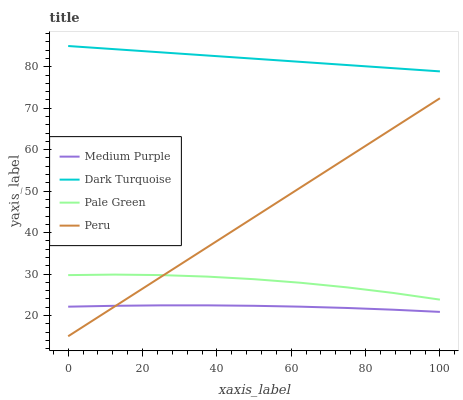Does Medium Purple have the minimum area under the curve?
Answer yes or no. Yes. Does Dark Turquoise have the maximum area under the curve?
Answer yes or no. Yes. Does Pale Green have the minimum area under the curve?
Answer yes or no. No. Does Pale Green have the maximum area under the curve?
Answer yes or no. No. Is Peru the smoothest?
Answer yes or no. Yes. Is Pale Green the roughest?
Answer yes or no. Yes. Is Dark Turquoise the smoothest?
Answer yes or no. No. Is Dark Turquoise the roughest?
Answer yes or no. No. Does Peru have the lowest value?
Answer yes or no. Yes. Does Pale Green have the lowest value?
Answer yes or no. No. Does Dark Turquoise have the highest value?
Answer yes or no. Yes. Does Pale Green have the highest value?
Answer yes or no. No. Is Medium Purple less than Dark Turquoise?
Answer yes or no. Yes. Is Dark Turquoise greater than Peru?
Answer yes or no. Yes. Does Pale Green intersect Peru?
Answer yes or no. Yes. Is Pale Green less than Peru?
Answer yes or no. No. Is Pale Green greater than Peru?
Answer yes or no. No. Does Medium Purple intersect Dark Turquoise?
Answer yes or no. No. 